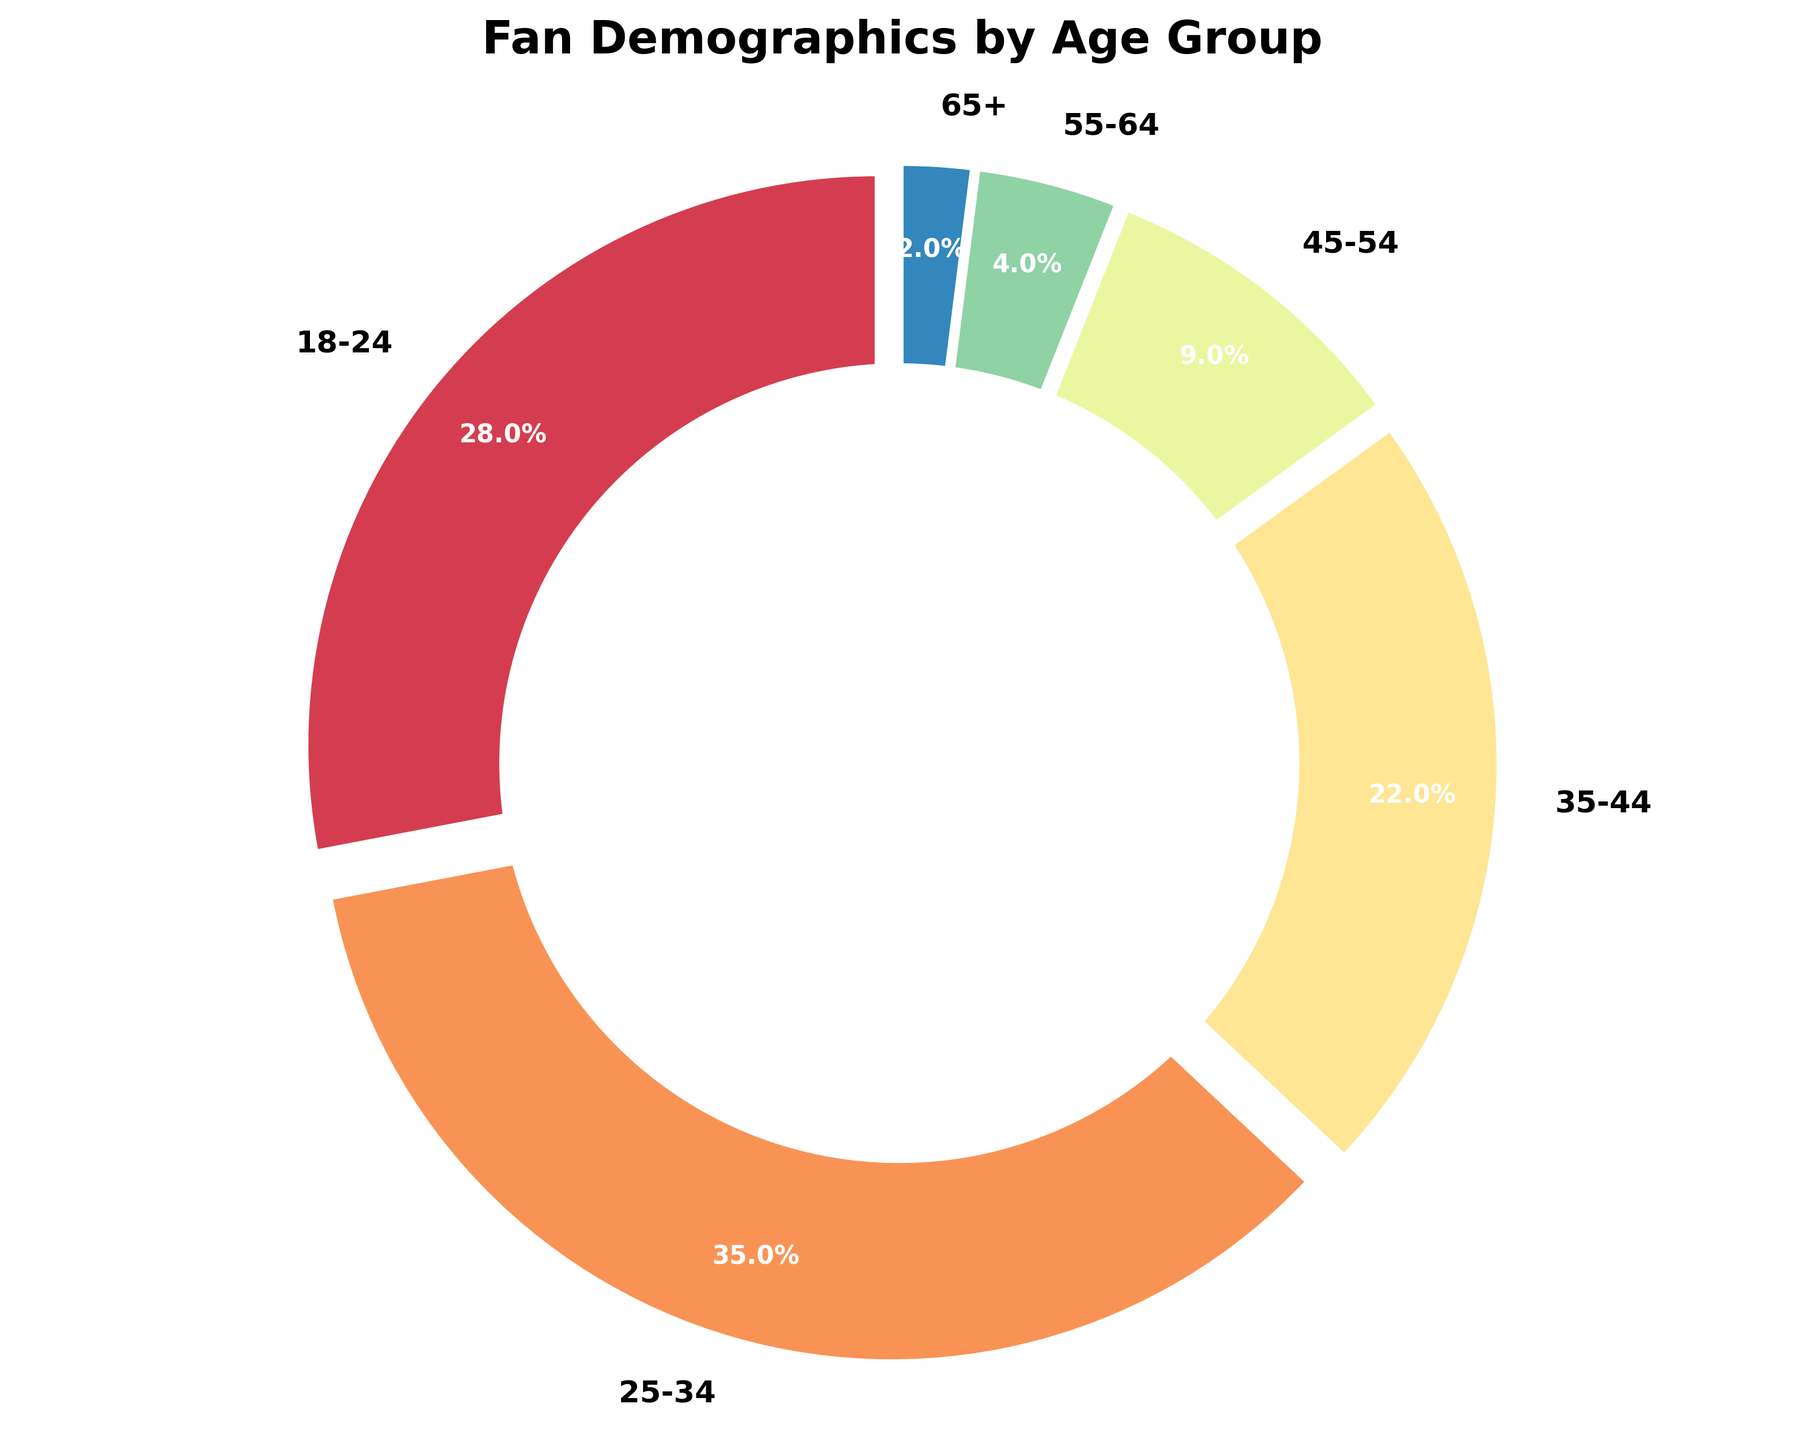What percentage of fans are aged between 35-44? This question looks at the specific age demographic of fans aged between 35-44. The pie chart segment labeled "35-44" corresponds to this demographic, showing a percentage value inside the segment.
Answer: 22% Which age group has the largest percentage of fans? This question is asking for the age demographic with the highest fan percentage. By comparing the pie chart segments, we can see that the segment labeled "25-34" is the largest.
Answer: 25-34 What is the combined percentage of fans under age 35? To find the combined percentage of fans under age 35, sum the values for the "18-24" and "25-34" segments. 28% (18-24) + 35% (25-34) gives 63%.
Answer: 63% Which age group has the smallest fan base, and what is the percentage? This question looks at identifying the smallest segment in the pie chart. The visually smallest segment is labeled "65+", showing the lowest percentage value.
Answer: 2% Is the percentage of fans aged 18-24 greater than those aged 45-54? To answer this, compare the two segments labeled "18-24" and "45-54". The percentage for "18-24" is 28% which is greater than the 9% for "45-54".
Answer: Yes How many age groups have a higher percentage of fans than the 35-44 group? This question involves counting the segments with a higher percentage than "35-44". Only "18-24" (28%) and "25-34" (35%) are greater than "35-44" (22%).
Answer: 2 What is the difference in percentage between fans aged 25-34 and 45-54? This requires finding the difference between the two groups' percentages. 35% (25-34) - 9% (45-54) = 26%.
Answer: 26% What’s the total percentage of fans aged 35 and older? Sum the percentages for age groups 35-44, 45-54, 55-64, and 65+. 22% (35-44) + 9% (45-54) + 4% (55-64) + 2% (65+) = 37%.
Answer: 37% Which color represents the age group with the highest percentage of fans? To determine this, identify the color of the largest segment in the pie chart, which represents the age group 25-34.
Answer: Depends on the color scheme (not seeing the figure) Is the percentage of fans aged 55-64 less than 5%? By examining the segment labeled "55-64", we see that the percentage is shown as 4%, which is indeed less than 5%.
Answer: Yes 